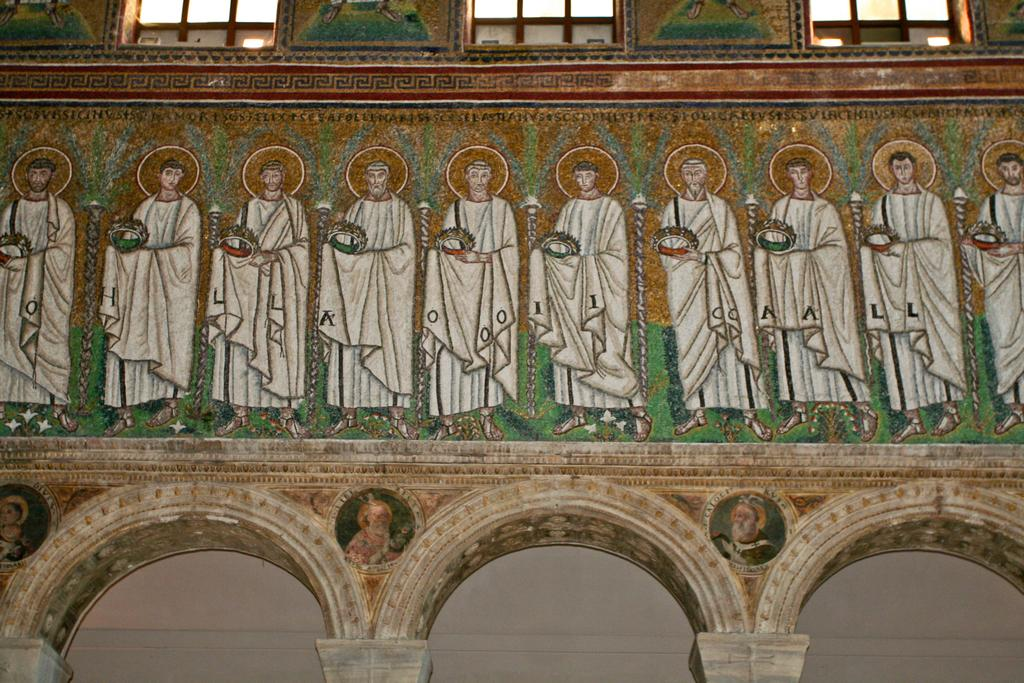What is depicted on the wall in the image? There is a painting of people on the wall. What architectural feature can be seen in the image? There are windows visible in the image. Can you see a hen at the seashore in the image? There is no hen or seashore present in the image. Is there a kitten playing with a ball of yarn in the image? There is no kitten or ball of yarn present in the image. 